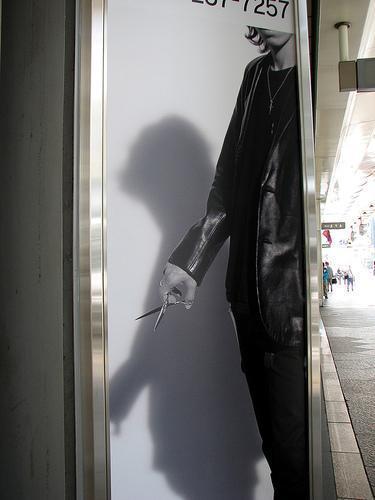How many pairs of scissors is the person holding?
Give a very brief answer. 1. How many necklaces is the person wearing?
Give a very brief answer. 1. 